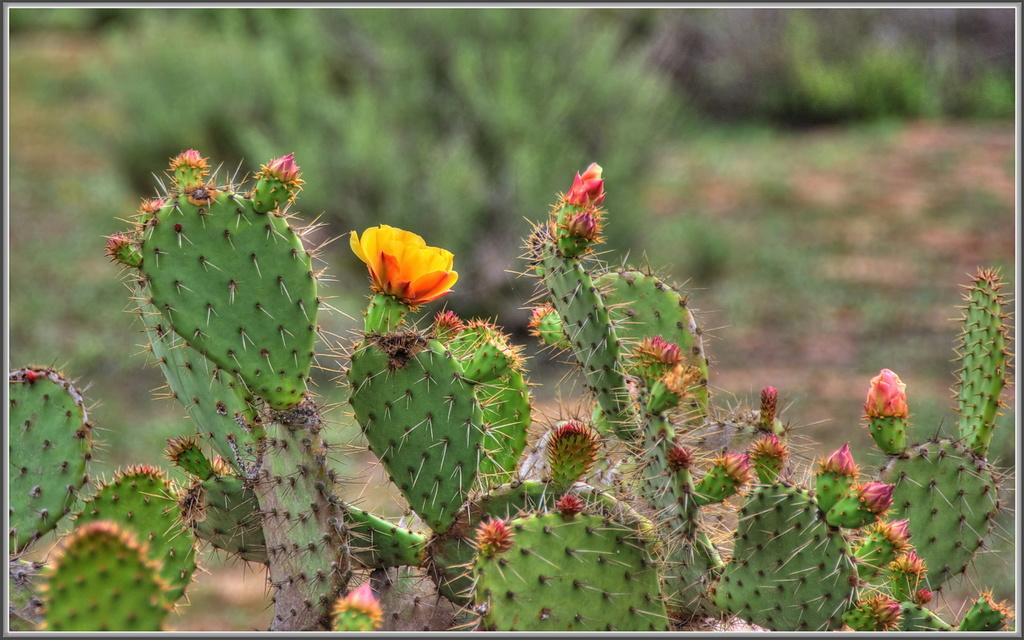What type of plants can be seen in the image? There are plants with flowers in the image. Where are the plants located in the image? The plants are on the ground in the image. Who is the owner of the baby in the image? There is no baby present in the image, so it is not possible to determine the owner. 